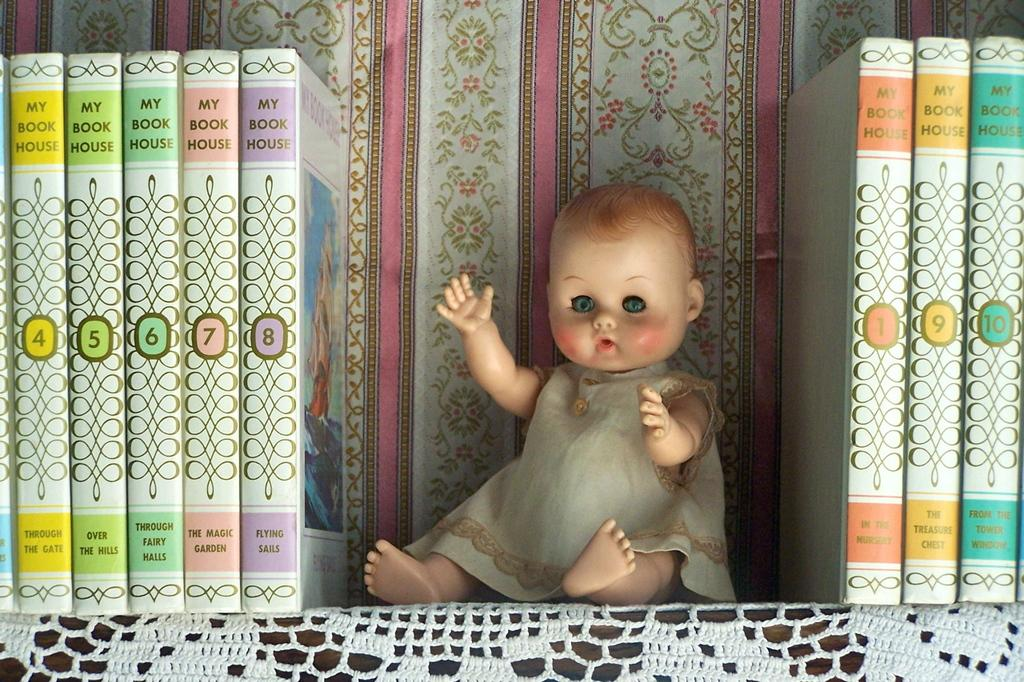<image>
Give a short and clear explanation of the subsequent image. A creepy baby doll on a shelf in between a set of books called my book house. 